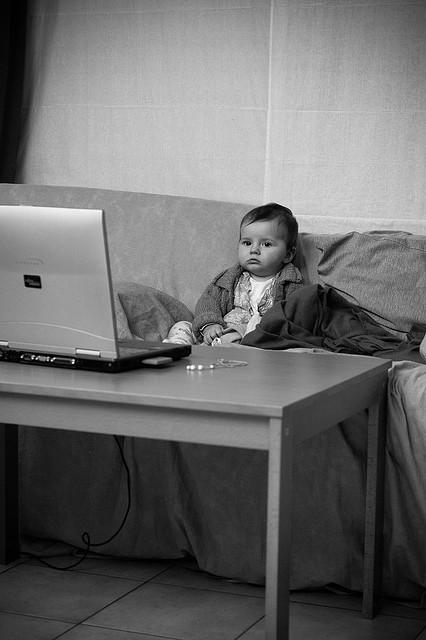Is anyone working on the laptop?
Keep it brief. No. Did the child just take a bath?
Quick response, please. No. Is this hotel room?
Concise answer only. No. What kind of room is the baby in?
Write a very short answer. Living room. Is this an apple laptop?
Write a very short answer. No. Which room is this?
Concise answer only. Living room. Who is sitting down?
Give a very brief answer. Baby. During which decade was this photograph taken?
Short answer required. 2000. How many tablecloths have been used?
Be succinct. 0. Is this baby happy?
Keep it brief. No. Is there a picture of a bird?
Keep it brief. No. What brand is the laptop?
Quick response, please. Hp. What is the baby sitting on?
Give a very brief answer. Couch. Where is the baby?
Be succinct. Couch. Is the subject wearing ski shoes?
Write a very short answer. No. Upon what is the child sitting?
Short answer required. Couch. Are the kids having fun?
Answer briefly. No. What occupation or hobby does the person who lives here likely have?
Write a very short answer. Drooling. Is this person returning from a trip?
Be succinct. No. Is there a coffee pot on the table?
Short answer required. No. What is sitting on the bed?
Answer briefly. Baby. What is he lying on?
Give a very brief answer. Couch. What is laying on the bed?
Concise answer only. Baby. What is under the table?
Answer briefly. Floor. Is the baby happy?
Short answer required. No. Could this be a scene from a movie?
Give a very brief answer. No. What is the floor material made of?
Keep it brief. Tile. What is laying on the table?
Give a very brief answer. Laptop. What animals are shown?
Concise answer only. 0. What event is this?
Concise answer only. Birthday. What is the child lying on?
Answer briefly. Couch. Is the child resting or active?
Quick response, please. Resting. What is on the table in front of the baby?
Concise answer only. Laptop. What room is this most likely taking place in?
Give a very brief answer. Living room. What room is this?
Short answer required. Living room. What type of flooring is in this room?
Keep it brief. Tile. How tall is the little girl?
Keep it brief. 2 feet. What is the person on the couch doing?
Quick response, please. Sitting. Is he sleeping?
Write a very short answer. No. Is the person sleeping?
Concise answer only. No. Does that child look bored?
Answer briefly. Yes. What color is the 'moustache'?
Be succinct. Black. 